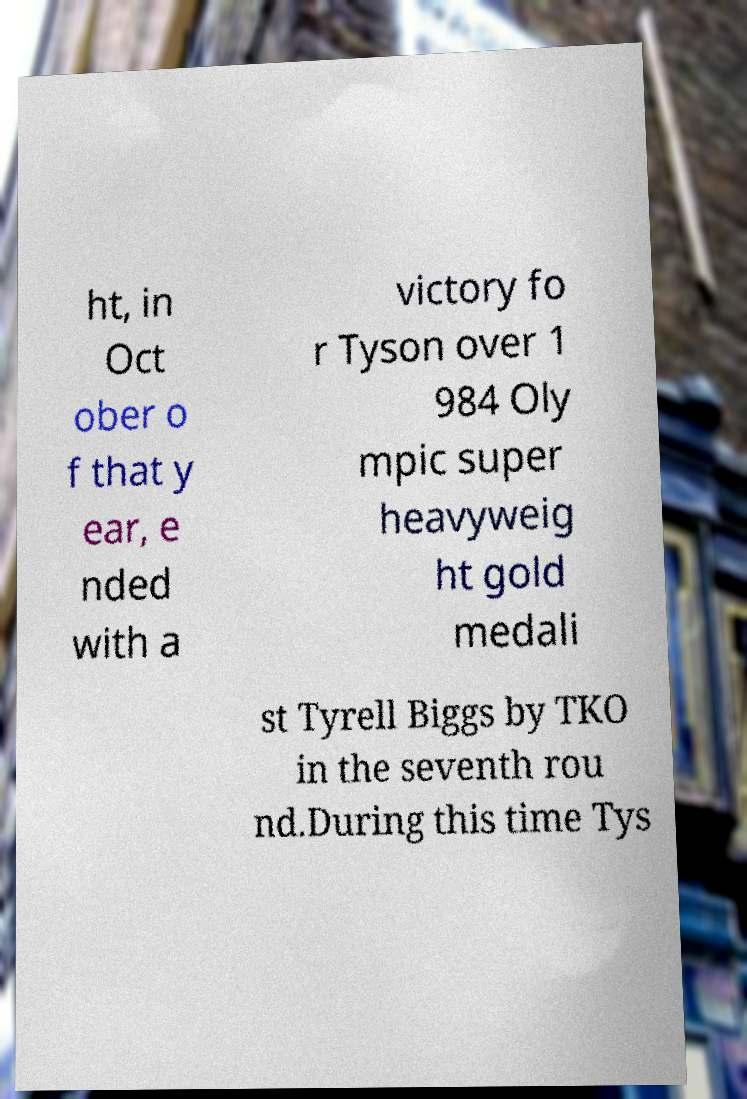What messages or text are displayed in this image? I need them in a readable, typed format. ht, in Oct ober o f that y ear, e nded with a victory fo r Tyson over 1 984 Oly mpic super heavyweig ht gold medali st Tyrell Biggs by TKO in the seventh rou nd.During this time Tys 